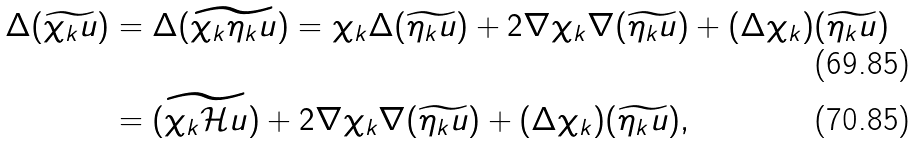Convert formula to latex. <formula><loc_0><loc_0><loc_500><loc_500>\Delta ( \widetilde { \chi _ { k } u } ) & = \Delta ( \widetilde { \chi _ { k } \eta _ { k } u } ) = \chi _ { k } \Delta ( \widetilde { \eta _ { k } u } ) + 2 \nabla \chi _ { k } \nabla ( \widetilde { \eta _ { k } u } ) + ( \Delta \chi _ { k } ) ( \widetilde { \eta _ { k } u } ) \\ & = ( \widetilde { \chi _ { k } \mathcal { H } u } ) + 2 \nabla \chi _ { k } \nabla ( \widetilde { \eta _ { k } u } ) + ( \Delta \chi _ { k } ) ( \widetilde { \eta _ { k } u } ) ,</formula> 